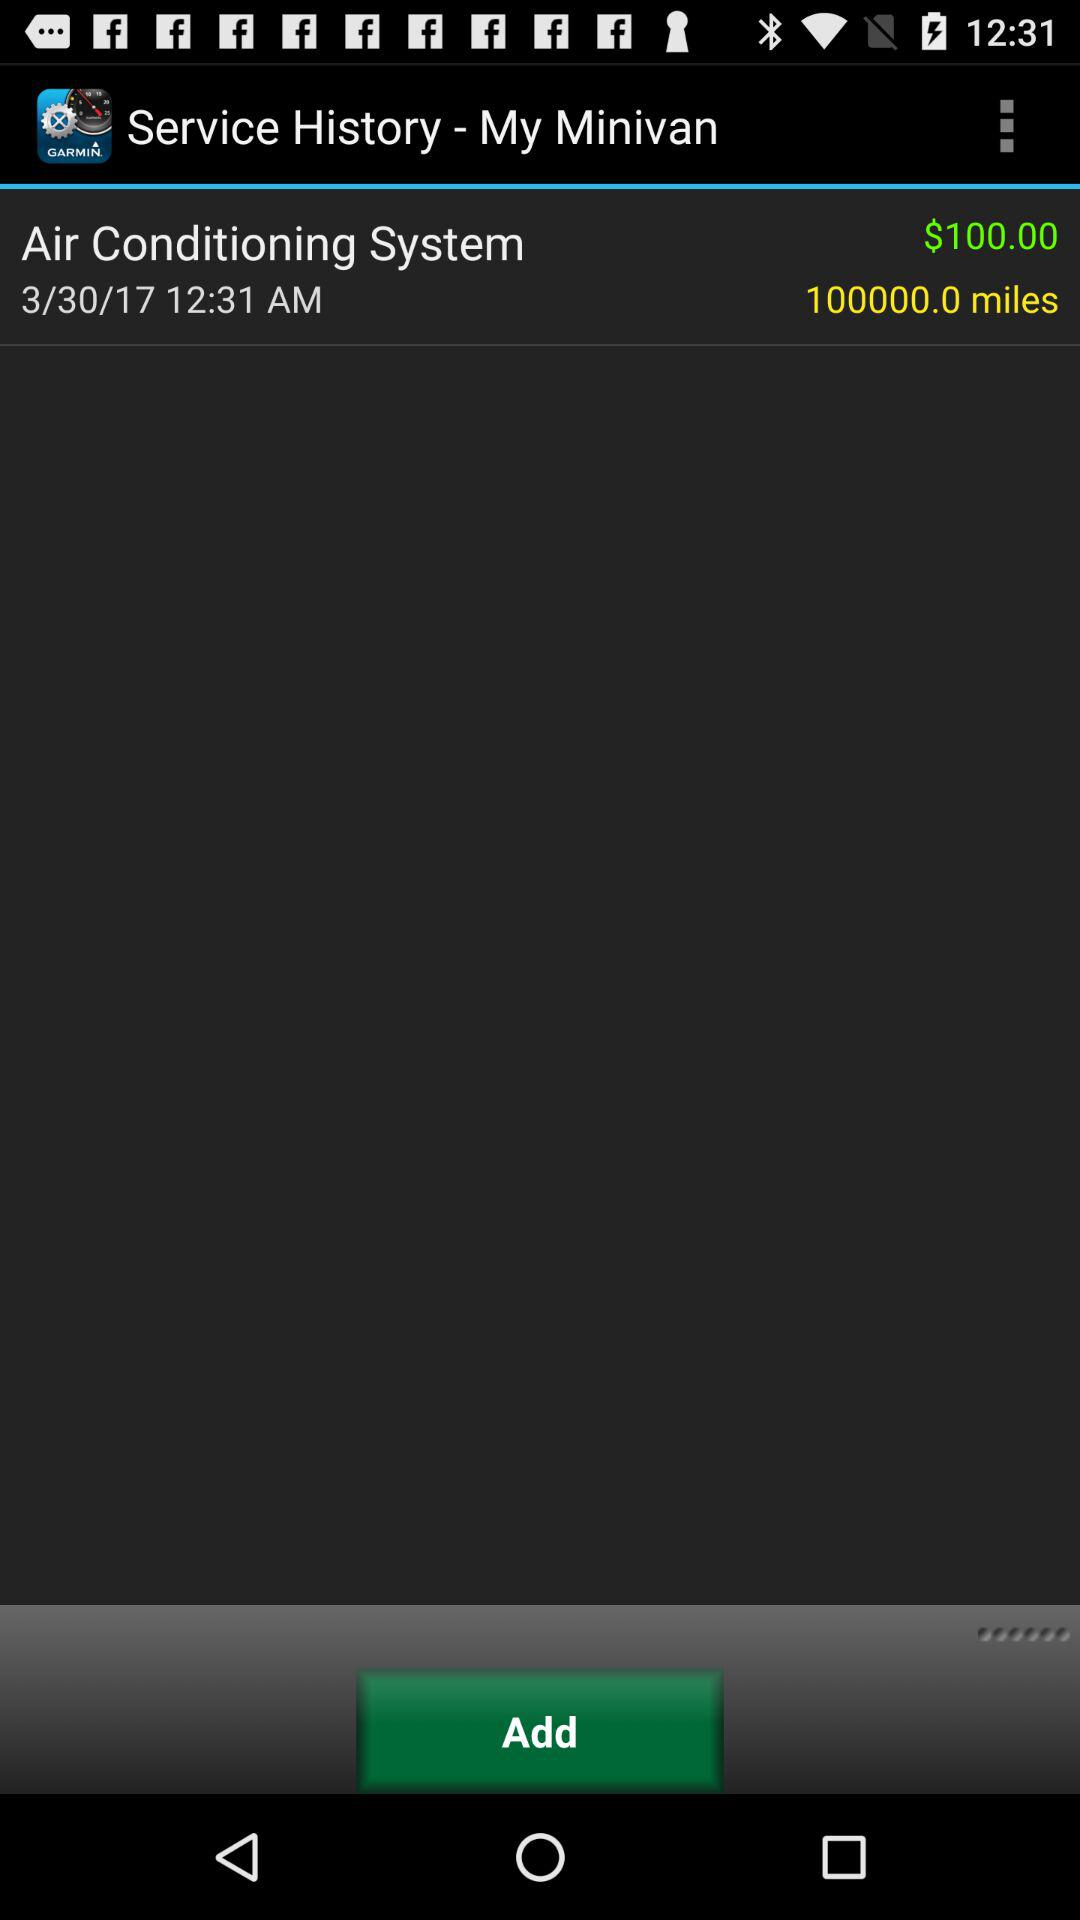What is the service charge? The service charge is 100 dollars. 